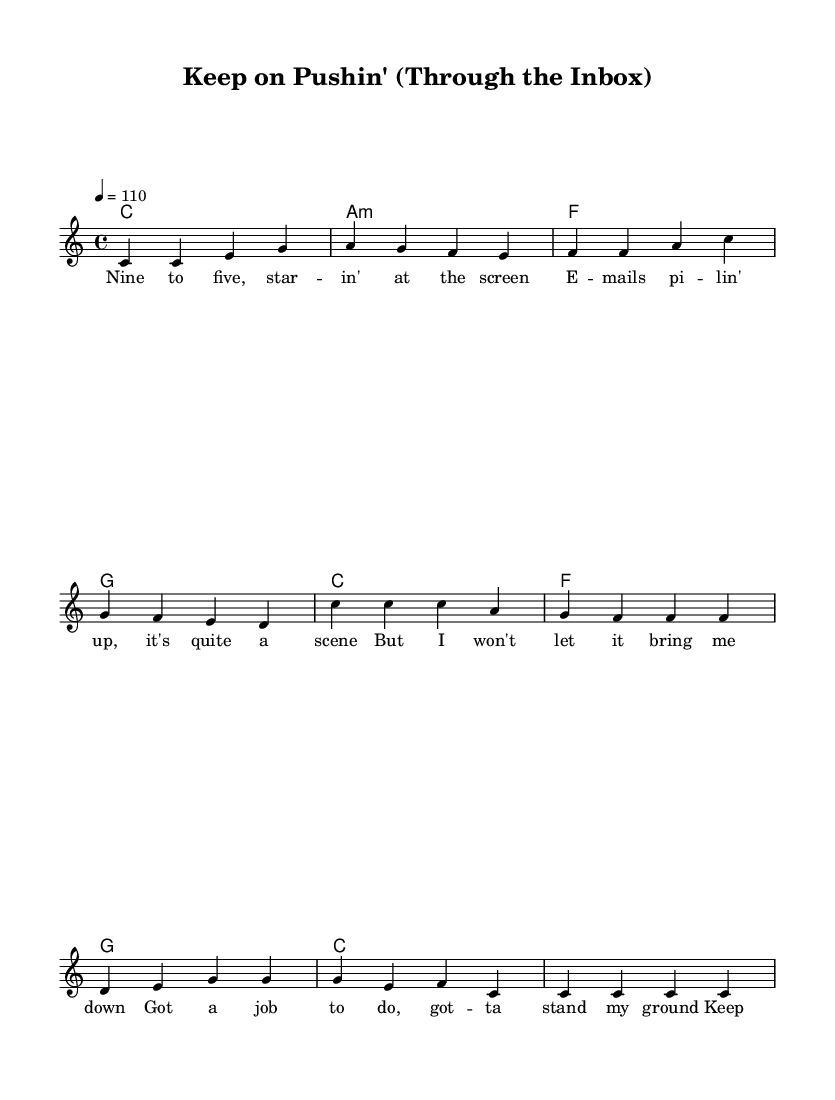What is the key signature of this music? The key signature is indicated at the beginning of the staff. Here, it is C major, which contains no sharps or flats.
Answer: C major What is the time signature of this music? The time signature is also shown at the beginning, and in this case, it is 4/4, meaning there are four beats in a measure and the quarter note gets one beat.
Answer: 4/4 What is the tempo marking for this piece? The tempo marking is found near the top of the score and is written as "4 = 110". This indicates the speed of the music, suggesting that there should be 110 beats per minute.
Answer: 110 How many measures are in the verse? To find the number of measures in the verse, we can count the measures under the verse lyrics. There are four sets of beats, leading to a total of four measures.
Answer: 4 What are the first two chords of the verse? The verse begins with two chords, which are indicated in the chord section at the beginning of the staff. The first two chords are C major and A minor.
Answer: C and A minor What theme is represented in the lyrics of this song? The lyrics reflect a theme of perseverance in the workplace, discussing challenges and the determination to succeed despite difficulties like busy emails and troubleshooting servers.
Answer: Perseverance What emotion does the chorus convey? The chorus expresses determination and pride combined with a sense of unwavering commitment to completing the job, as indicated by phrases like "Keep on pushin' through the inbox."
Answer: Determination 